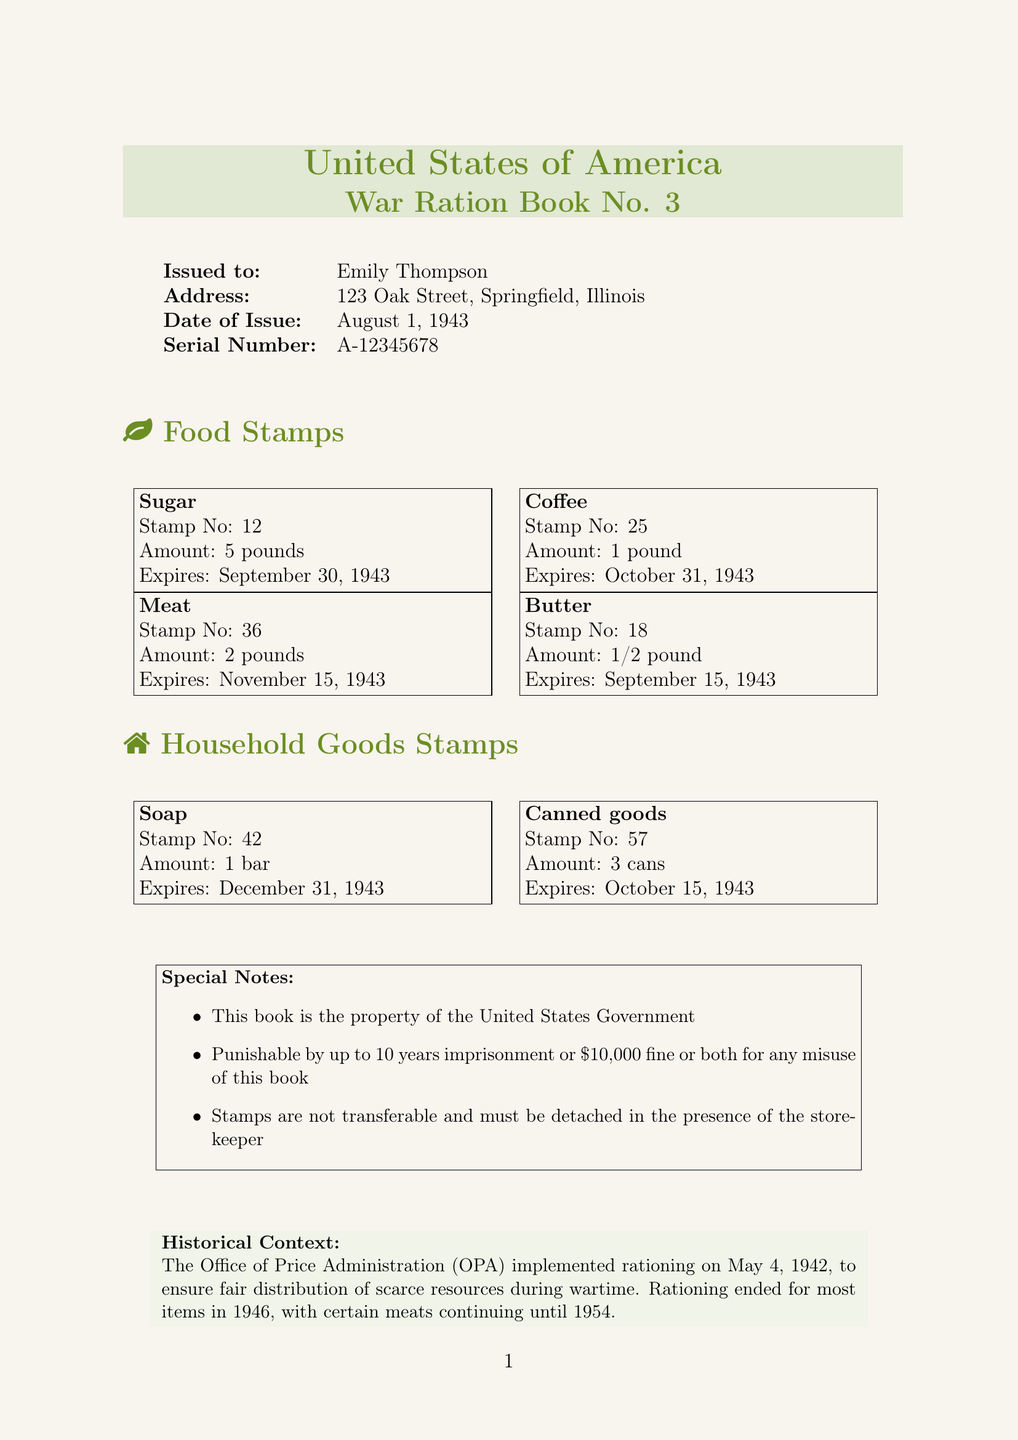What is the title of the ration book? The title is found at the top of the document, indicating the name of the ration book.
Answer: United States of America War Ration Book No. 3 Who is the ration book issued to? The issued name is listed in the details section of the document.
Answer: Emily Thompson What is the serial number of the ration book? The serial number is provided in the issued details of the document.
Answer: A-12345678 How many pounds of sugar can be purchased with stamp number 12? The document specifies the amount associated with each food stamp.
Answer: 5 pounds What is the expiration date for the coffee stamp? The expiration date for each item is noted in their stamp details.
Answer: October 31, 1943 What were neighbors likely to do with excess stamps? This action is mentioned under impact on daily life related to community behavior during rationing.
Answer: Trade stamps What is the purpose of rationing mentioned in the document? The document provides context for rationing, explaining its significance during wartime.
Answer: Ensure fair distribution What is a consequence of misusing the ration book? The document includes special notes that clarify legal consequences for misuse.
Answer: 10 years imprisonment Which agency was responsible for implementing rationing? The responsible agency is identified in the historical context section of the document.
Answer: Office of Price Administration 